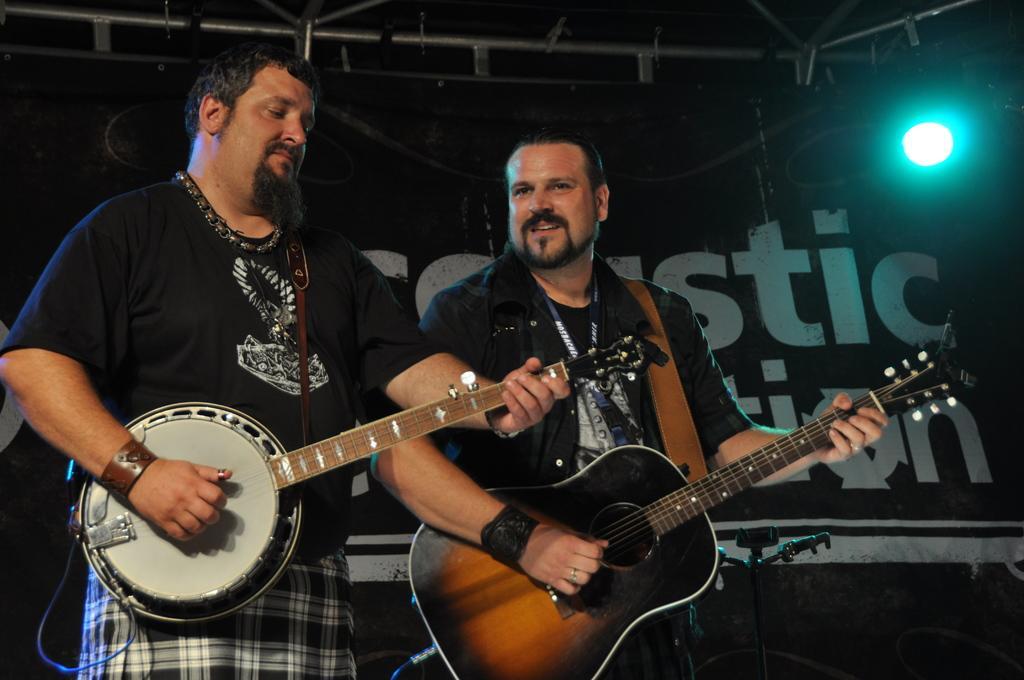In one or two sentences, can you explain what this image depicts? There are two persons standing and holding a guitar in their hands and there is a light in the right top corner. 